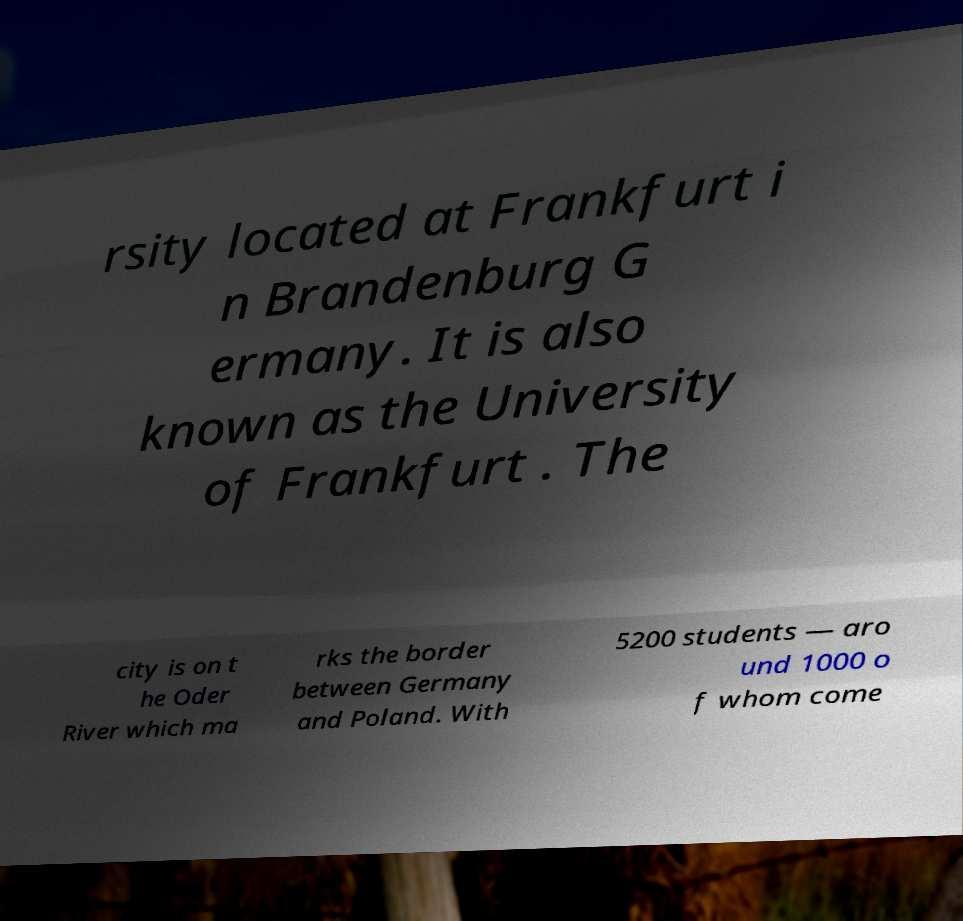For documentation purposes, I need the text within this image transcribed. Could you provide that? rsity located at Frankfurt i n Brandenburg G ermany. It is also known as the University of Frankfurt . The city is on t he Oder River which ma rks the border between Germany and Poland. With 5200 students — aro und 1000 o f whom come 